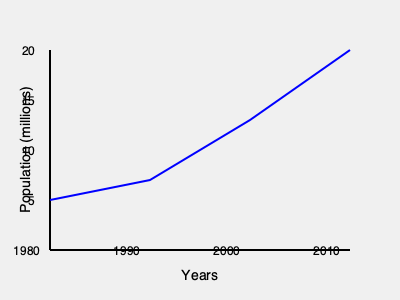Based on the graph showing population growth over time, what was the approximate rate of population increase between 1990 and 2000? To find the rate of population increase between 1990 and 2000, we need to:

1. Identify the population values for 1990 and 2000:
   - 1990 (second data point): approximately 7 million
   - 2000 (third data point): approximately 13 million

2. Calculate the total increase:
   $13 \text{ million} - 7 \text{ million} = 6 \text{ million}$

3. Determine the time period:
   $2000 - 1990 = 10 \text{ years}$

4. Calculate the rate of increase per year:
   $\frac{6 \text{ million}}{10 \text{ years}} = 0.6 \text{ million per year}$

5. Convert to a more standard unit:
   $0.6 \text{ million per year} = 600,000 \text{ per year}$

Therefore, the approximate rate of population increase between 1990 and 2000 was 600,000 per year.
Answer: 600,000 per year 